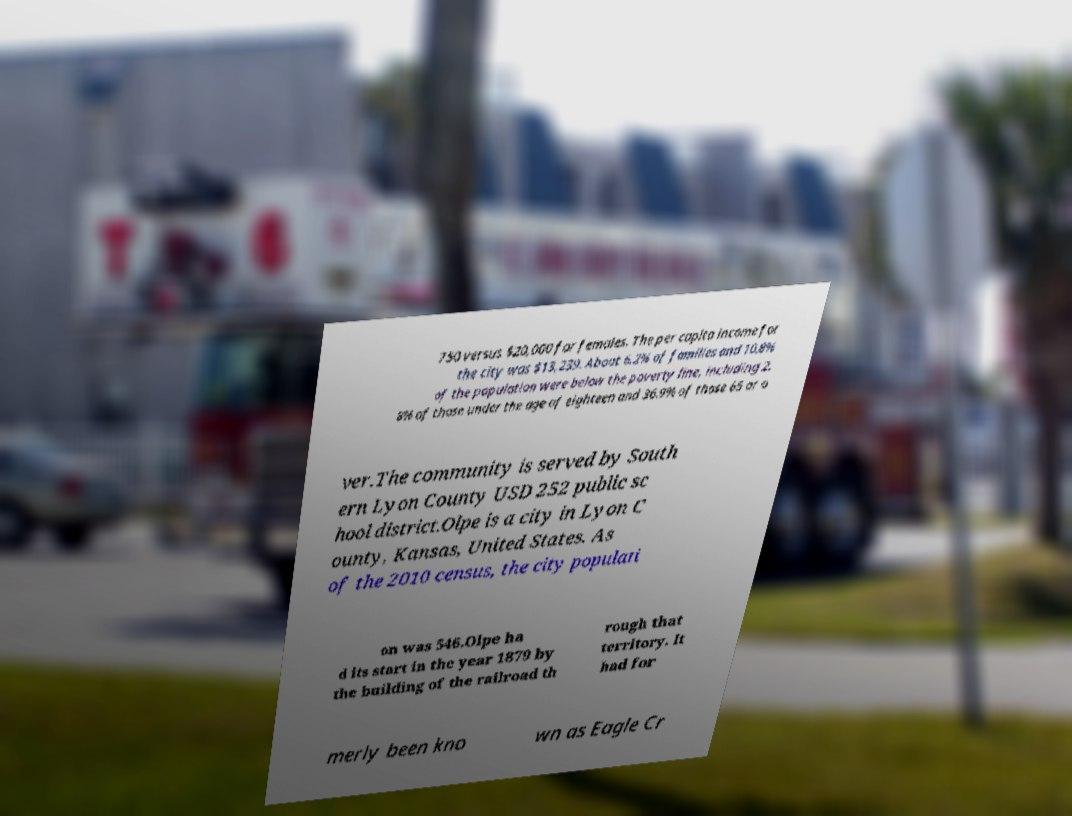There's text embedded in this image that I need extracted. Can you transcribe it verbatim? 750 versus $20,000 for females. The per capita income for the city was $13,239. About 6.2% of families and 10.8% of the population were below the poverty line, including 2. 8% of those under the age of eighteen and 36.9% of those 65 or o ver.The community is served by South ern Lyon County USD 252 public sc hool district.Olpe is a city in Lyon C ounty, Kansas, United States. As of the 2010 census, the city populati on was 546.Olpe ha d its start in the year 1879 by the building of the railroad th rough that territory. It had for merly been kno wn as Eagle Cr 